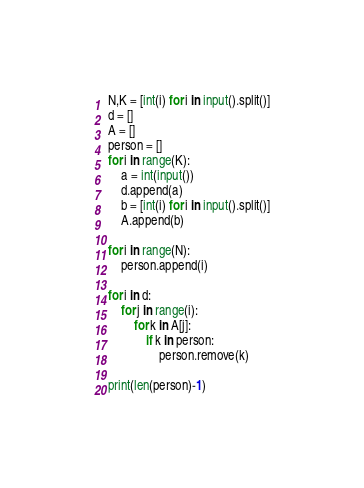<code> <loc_0><loc_0><loc_500><loc_500><_Python_>N,K = [int(i) for i in input().split()]
d = []
A = []
person = []
for i in range(K):
    a = int(input())
    d.append(a)
    b = [int(i) for i in input().split()]
    A.append(b)

for i in range(N):
    person.append(i)

for i in d:
    for j in range(i):
        for k in A[j]:
            if k in person:
                person.remove(k)

print(len(person)-1)
</code> 